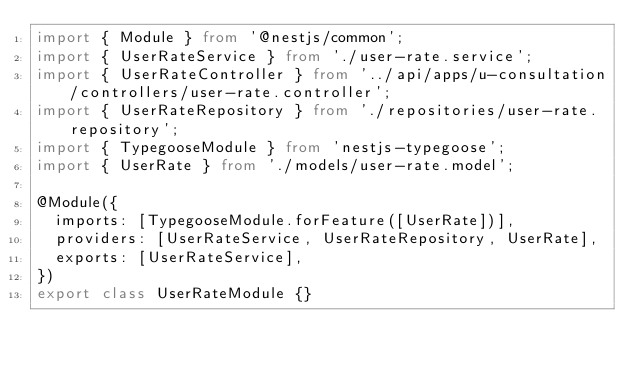<code> <loc_0><loc_0><loc_500><loc_500><_TypeScript_>import { Module } from '@nestjs/common';
import { UserRateService } from './user-rate.service';
import { UserRateController } from '../api/apps/u-consultation/controllers/user-rate.controller';
import { UserRateRepository } from './repositories/user-rate.repository';
import { TypegooseModule } from 'nestjs-typegoose';
import { UserRate } from './models/user-rate.model';

@Module({
  imports: [TypegooseModule.forFeature([UserRate])],
  providers: [UserRateService, UserRateRepository, UserRate],
  exports: [UserRateService],
})
export class UserRateModule {}
</code> 